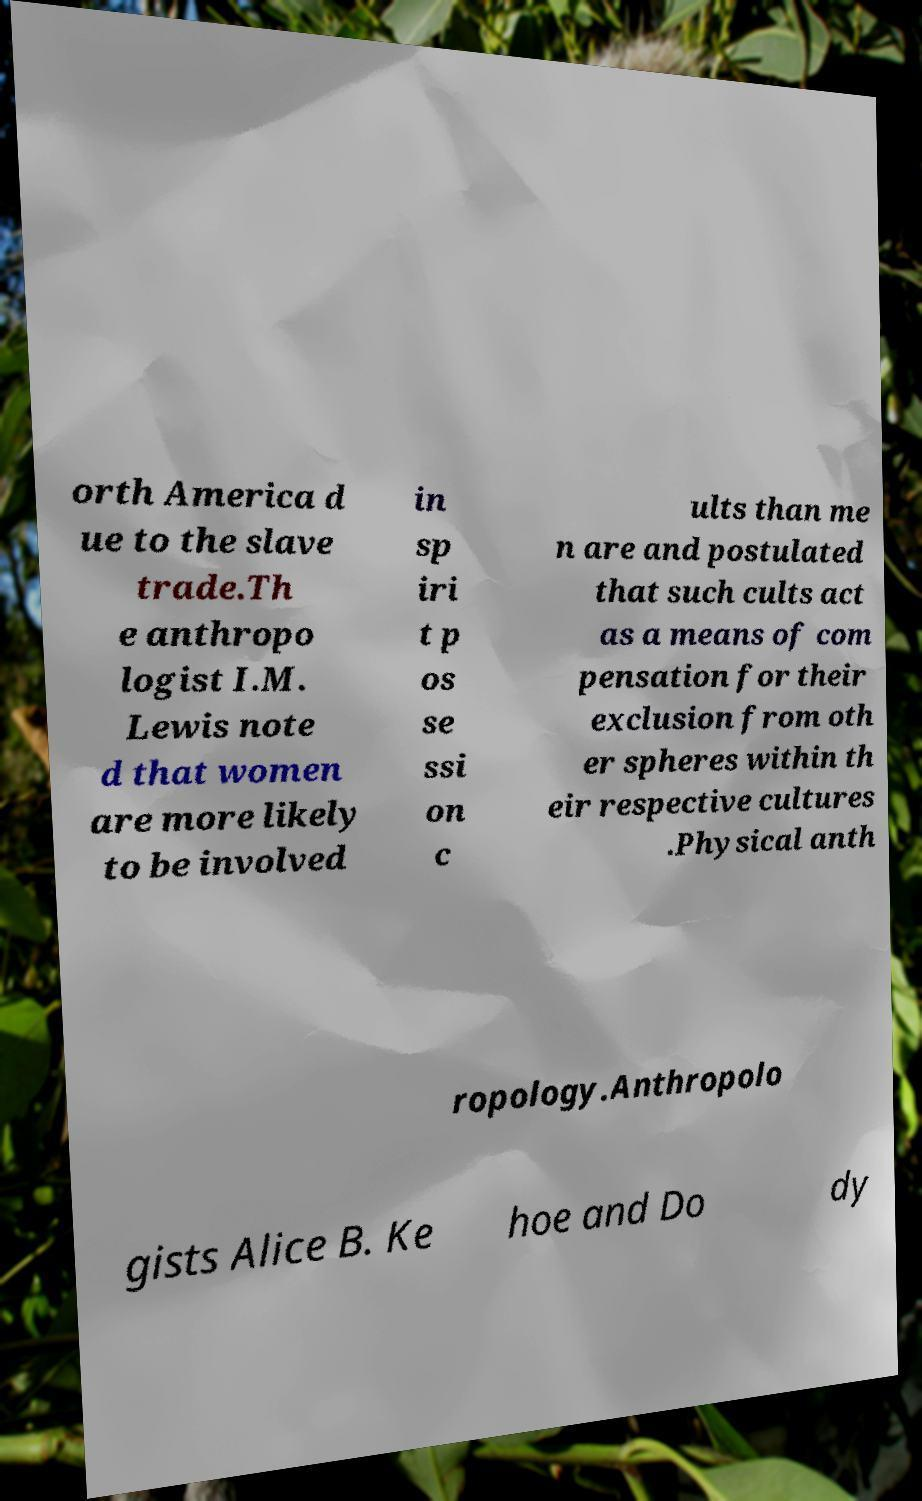Can you read and provide the text displayed in the image?This photo seems to have some interesting text. Can you extract and type it out for me? orth America d ue to the slave trade.Th e anthropo logist I.M. Lewis note d that women are more likely to be involved in sp iri t p os se ssi on c ults than me n are and postulated that such cults act as a means of com pensation for their exclusion from oth er spheres within th eir respective cultures .Physical anth ropology.Anthropolo gists Alice B. Ke hoe and Do dy 